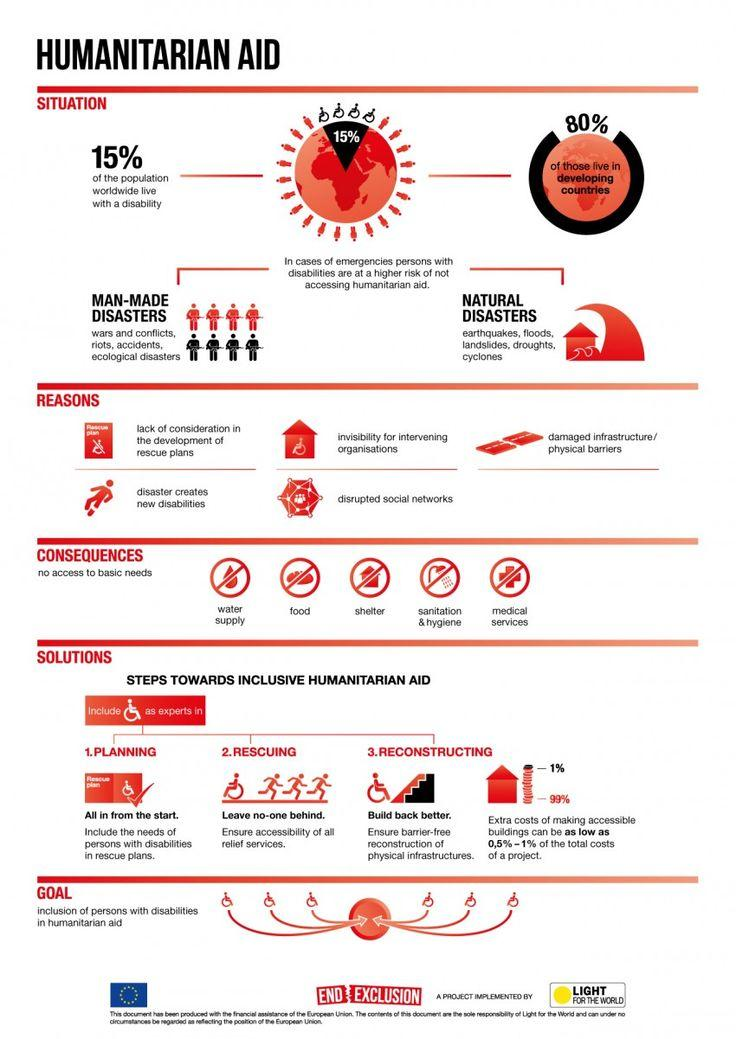Indicate a few pertinent items in this graphic. There are two types of disasters: man-made disasters and natural disasters. Approximately 20% of the population in developed countries has a disability. 